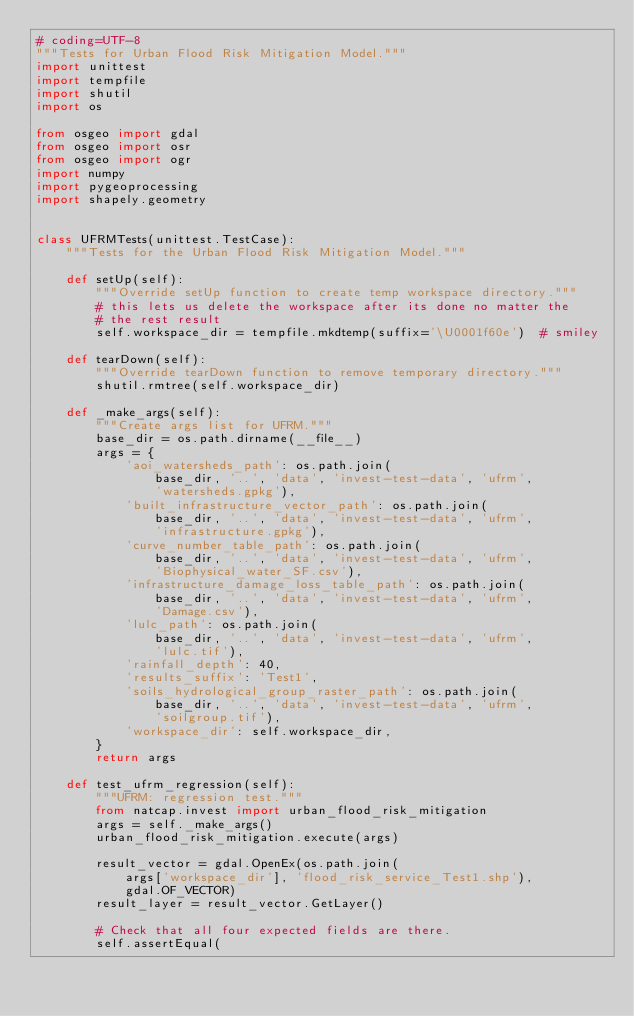Convert code to text. <code><loc_0><loc_0><loc_500><loc_500><_Python_># coding=UTF-8
"""Tests for Urban Flood Risk Mitigation Model."""
import unittest
import tempfile
import shutil
import os

from osgeo import gdal
from osgeo import osr
from osgeo import ogr
import numpy
import pygeoprocessing
import shapely.geometry


class UFRMTests(unittest.TestCase):
    """Tests for the Urban Flood Risk Mitigation Model."""

    def setUp(self):
        """Override setUp function to create temp workspace directory."""
        # this lets us delete the workspace after its done no matter the
        # the rest result
        self.workspace_dir = tempfile.mkdtemp(suffix='\U0001f60e')  # smiley

    def tearDown(self):
        """Override tearDown function to remove temporary directory."""
        shutil.rmtree(self.workspace_dir)

    def _make_args(self):
        """Create args list for UFRM."""
        base_dir = os.path.dirname(__file__)
        args = {
            'aoi_watersheds_path': os.path.join(
                base_dir, '..', 'data', 'invest-test-data', 'ufrm',
                'watersheds.gpkg'),
            'built_infrastructure_vector_path': os.path.join(
                base_dir, '..', 'data', 'invest-test-data', 'ufrm',
                'infrastructure.gpkg'),
            'curve_number_table_path': os.path.join(
                base_dir, '..', 'data', 'invest-test-data', 'ufrm',
                'Biophysical_water_SF.csv'),
            'infrastructure_damage_loss_table_path': os.path.join(
                base_dir, '..', 'data', 'invest-test-data', 'ufrm',
                'Damage.csv'),
            'lulc_path': os.path.join(
                base_dir, '..', 'data', 'invest-test-data', 'ufrm',
                'lulc.tif'),
            'rainfall_depth': 40,
            'results_suffix': 'Test1',
            'soils_hydrological_group_raster_path': os.path.join(
                base_dir, '..', 'data', 'invest-test-data', 'ufrm',
                'soilgroup.tif'),
            'workspace_dir': self.workspace_dir,
        }
        return args

    def test_ufrm_regression(self):
        """UFRM: regression test."""
        from natcap.invest import urban_flood_risk_mitigation
        args = self._make_args()
        urban_flood_risk_mitigation.execute(args)

        result_vector = gdal.OpenEx(os.path.join(
            args['workspace_dir'], 'flood_risk_service_Test1.shp'),
            gdal.OF_VECTOR)
        result_layer = result_vector.GetLayer()

        # Check that all four expected fields are there.
        self.assertEqual(</code> 